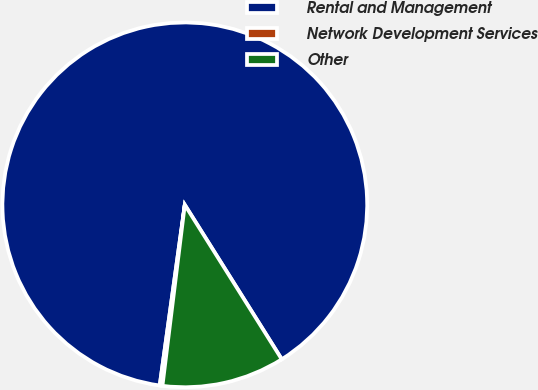Convert chart. <chart><loc_0><loc_0><loc_500><loc_500><pie_chart><fcel>Rental and Management<fcel>Network Development Services<fcel>Other<nl><fcel>88.88%<fcel>0.24%<fcel>10.88%<nl></chart> 